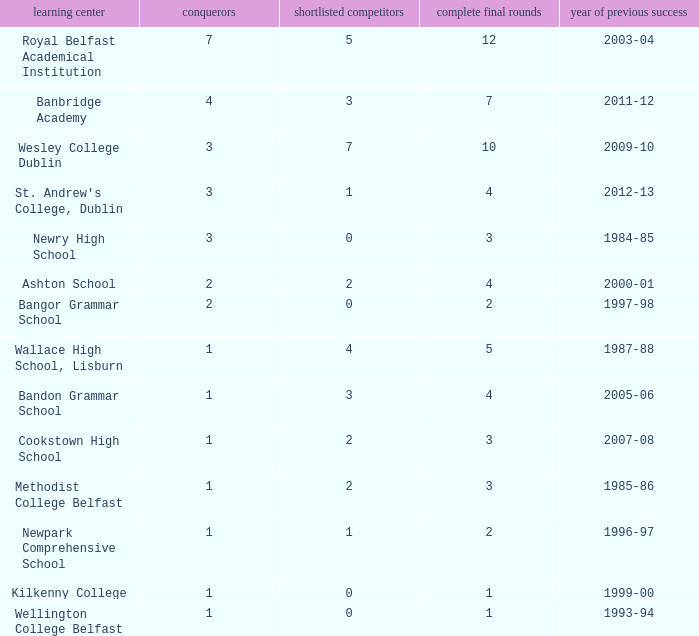How many times was banbridge academy the winner? 1.0. 